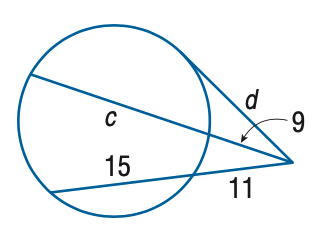Question: Find the variable of c to the nearest tenth. Assume that segments that appear to be tangent are tangent.
Choices:
A. 22.8
B. 23.8
C. 24.8
D. 25.8
Answer with the letter. Answer: A Question: Find the variable of d to the nearest tenth. Assume that segments that appear to be tangent are tangent.
Choices:
A. 12.8
B. 14.7
C. 16.9
D. 18.2
Answer with the letter. Answer: C 